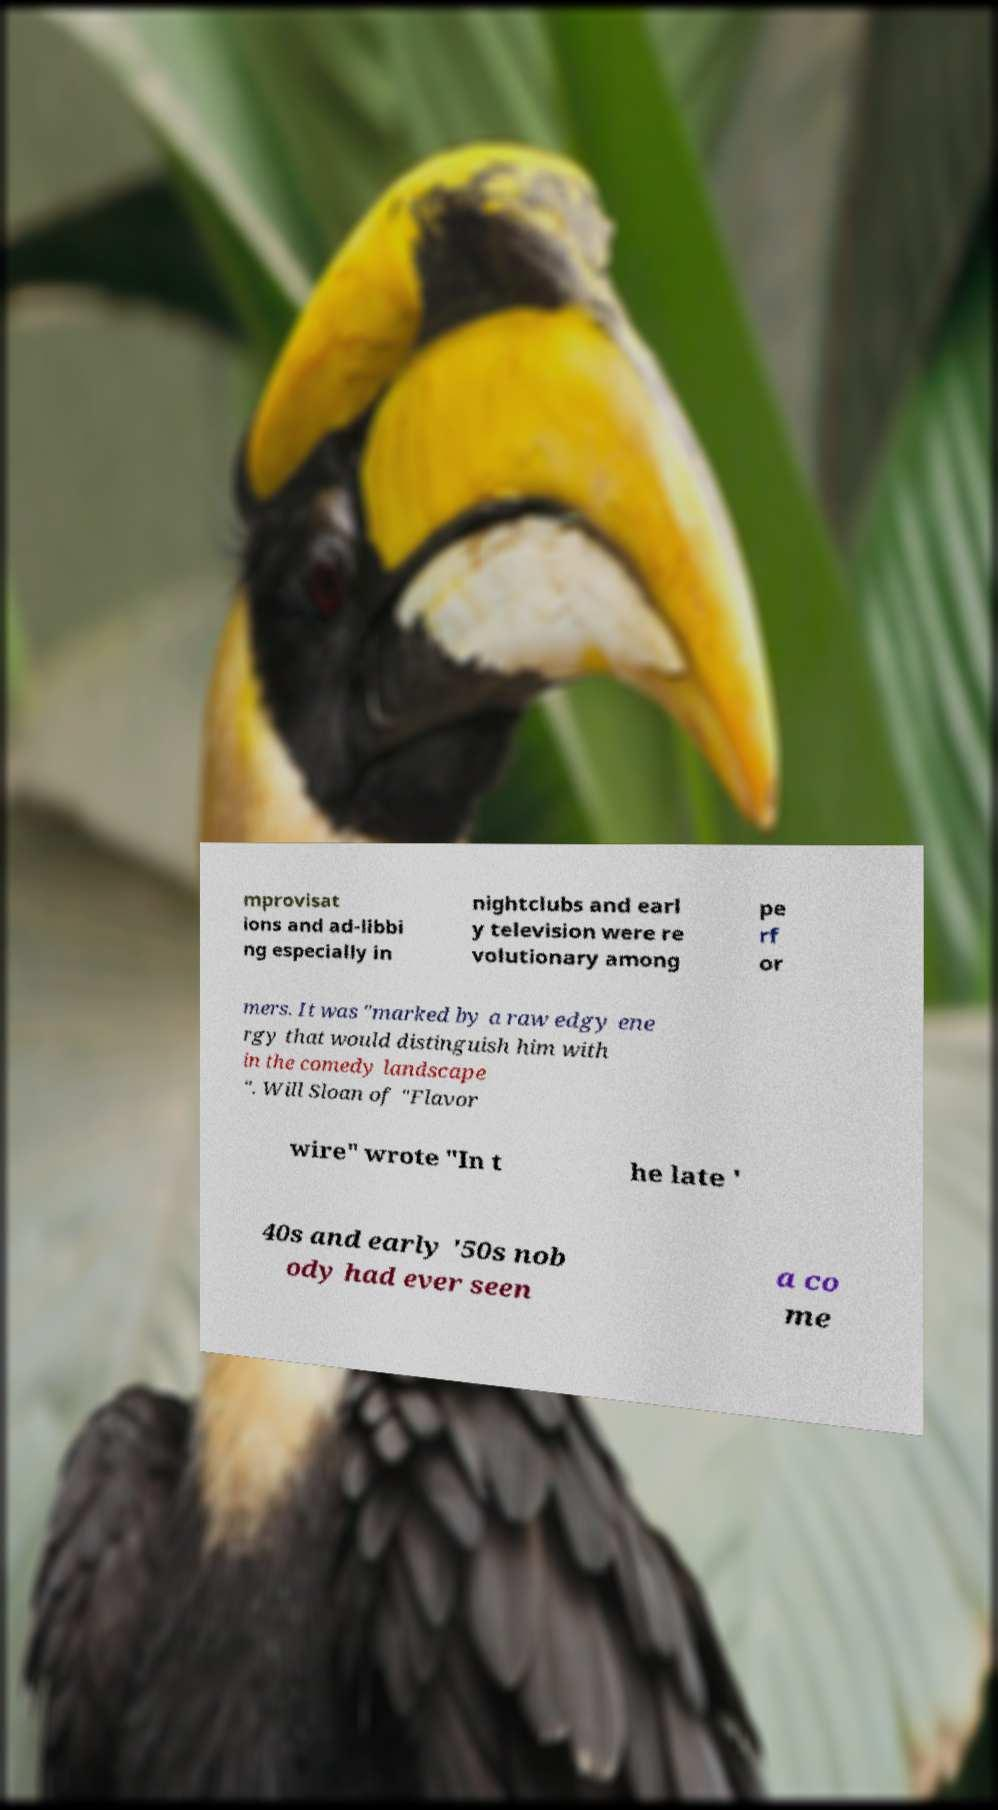Please read and relay the text visible in this image. What does it say? mprovisat ions and ad-libbi ng especially in nightclubs and earl y television were re volutionary among pe rf or mers. It was "marked by a raw edgy ene rgy that would distinguish him with in the comedy landscape ". Will Sloan of "Flavor wire" wrote "In t he late ' 40s and early '50s nob ody had ever seen a co me 